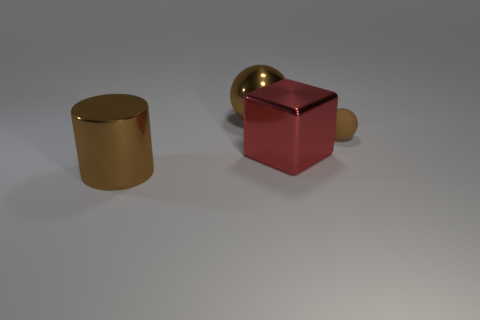Subtract 1 balls. How many balls are left? 1 Add 2 large shiny things. How many objects exist? 6 Subtract all blocks. How many objects are left? 3 Subtract all red shiny blocks. Subtract all metallic objects. How many objects are left? 0 Add 2 big objects. How many big objects are left? 5 Add 3 tiny matte things. How many tiny matte things exist? 4 Subtract 0 brown cubes. How many objects are left? 4 Subtract all blue spheres. Subtract all yellow blocks. How many spheres are left? 2 